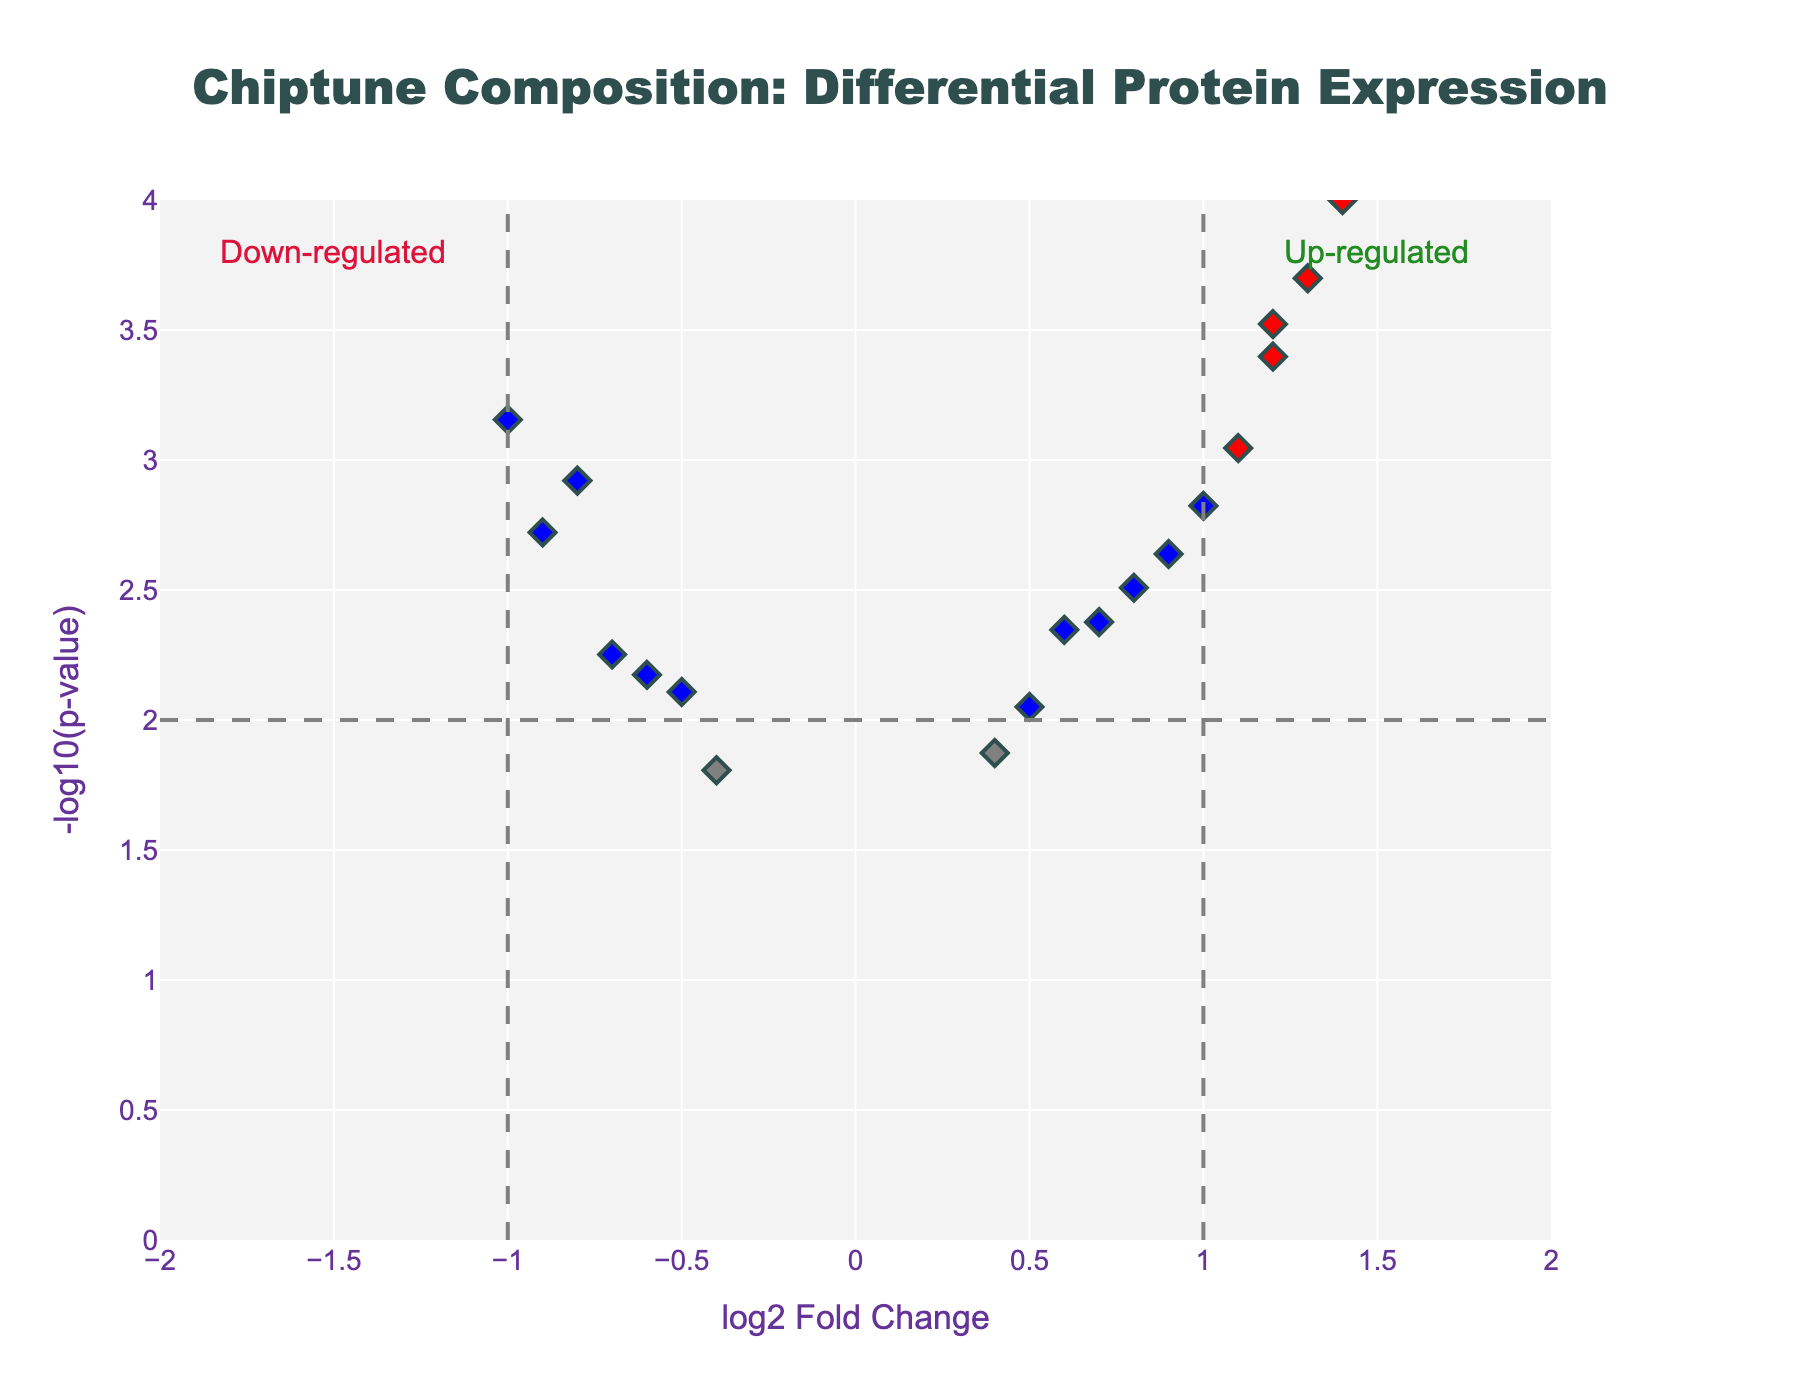What is the title of the figure? The title of the figure is typically displayed at the top of the plot and is clearly visible.
Answer: "Chiptune Composition: Differential Protein Expression" How many genes are significantly up-regulated based on the visual information in the figure? Significantly up-regulated genes are marked in red color and have positive log2 Fold Change values and p-values below the threshold. In the plot, count the red points to determine the answer.
Answer: 5 What does the y-axis represent? The y-axis is labeled with its description, which usually includes a mathematical transformation of the p-value. In this plot, it is labeled as -log10(p-value).
Answer: -log10(p-value) How many genes have a log2 Fold Change greater than 1 and a p-value less than 0.01? Genes with a log2 Fold Change greater than 1 and a p-value less than 0.01 are represented by red points on the right side of the vertical dashed line at x=1. Count these red points.
Answer: 4 Which gene has the most significant p-value, and what is its log2 Fold Change? The gene with the most significant p-value will be the point highest on the y-axis (-log10(p-value)). To find its log2 Fold Change, look at the corresponding x-axis value.
Answer: MYH3, 1.5 Compare the expression levels of CALM1 and HOMER1. Which gene shows greater fold change, and in which direction? Compare the x-axis positions of CALM1 and HOMER1 to determine which one has the greater absolute log2 Fold Change value. Check if they are to the left or right of the y-axis to determine the direction.
Answer: CALM1, up-regulated How many genes are highlighted in blue and what does their color indicate? Color coding and the number of blue points provide insight into their significance thresholds. Blue points indicate genes with p-values less than the threshold but log2 Fold Change within the range (-1, 1). Count the blue points on the plot.
Answer: 4, significant but low fold change What are the log2 Fold Change values for the lowest and highest p-value genes, and are they up-regulated or down-regulated? Locate the points corresponding to the lowest and highest p-values on the plot, then read their x-axis (log2 Fold Change) values. Also, determine if these values are positive (up-regulated) or negative (down-regulated).
Answer: Lowest: MYH3, 1.5, up-regulated; Highest: CAMK2A, -1.0, down-regulated How many genes fall within the non-significant category? Non-significant genes are represented by gray points. Count these points to find the total number of non-significant genes.
Answer: 4 